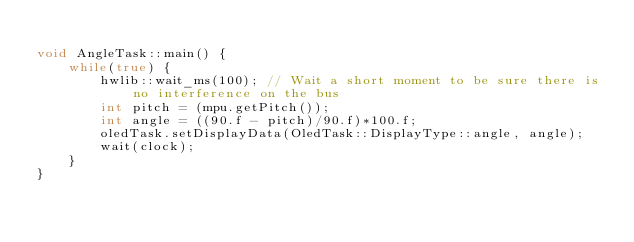Convert code to text. <code><loc_0><loc_0><loc_500><loc_500><_C++_>
void AngleTask::main() {
	while(true) {
		hwlib::wait_ms(100); // Wait a short moment to be sure there is no interference on the bus
		int pitch = (mpu.getPitch());
		int angle = ((90.f - pitch)/90.f)*100.f;
		oledTask.setDisplayData(OledTask::DisplayType::angle, angle);
		wait(clock);
	}
}</code> 